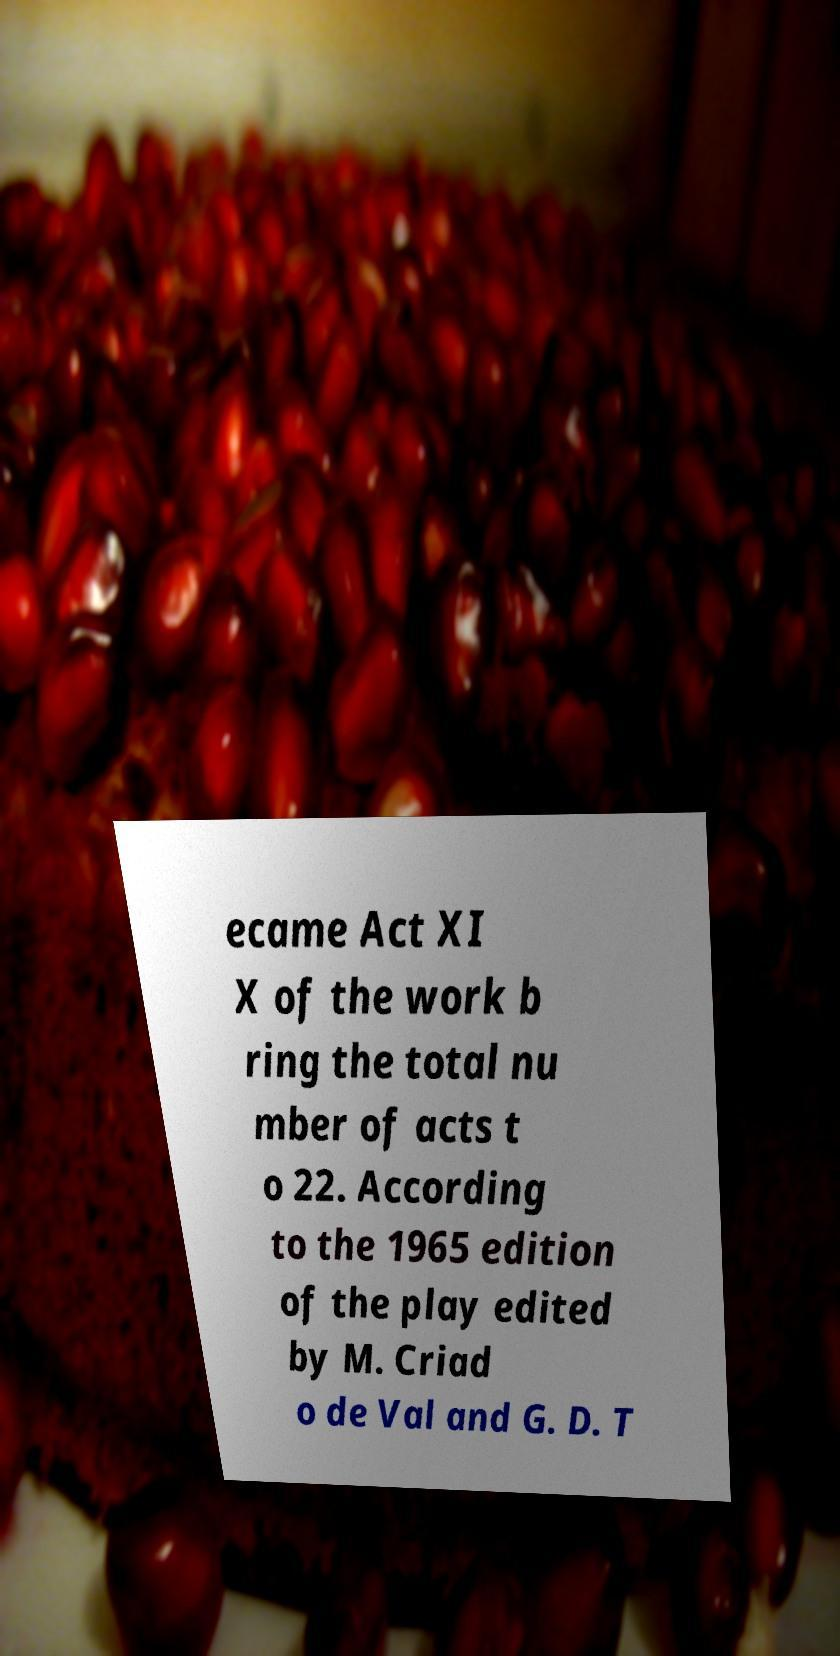Can you read and provide the text displayed in the image?This photo seems to have some interesting text. Can you extract and type it out for me? ecame Act XI X of the work b ring the total nu mber of acts t o 22. According to the 1965 edition of the play edited by M. Criad o de Val and G. D. T 